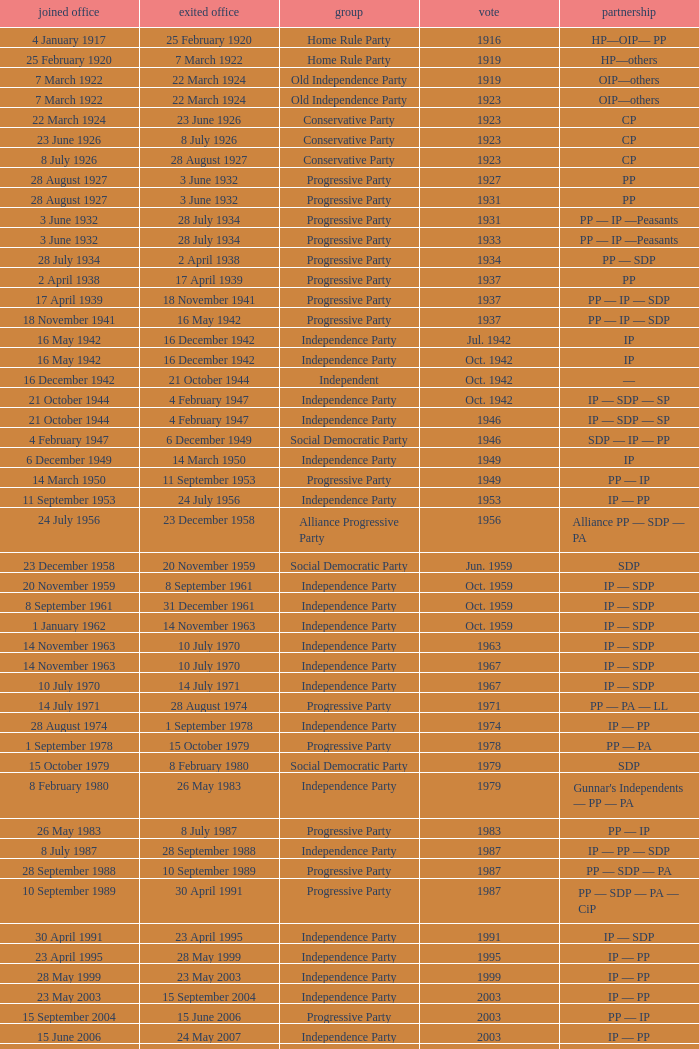When did the party elected in jun. 1959 enter office? 23 December 1958. 